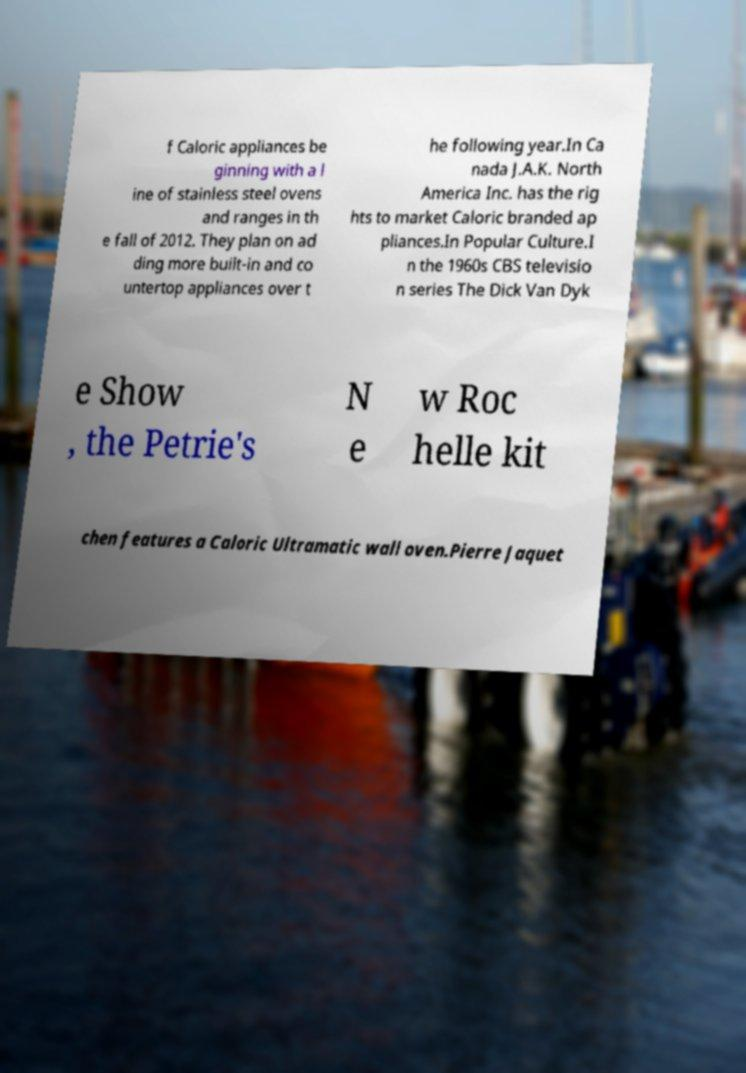What messages or text are displayed in this image? I need them in a readable, typed format. f Caloric appliances be ginning with a l ine of stainless steel ovens and ranges in th e fall of 2012. They plan on ad ding more built-in and co untertop appliances over t he following year.In Ca nada J.A.K. North America Inc. has the rig hts to market Caloric branded ap pliances.In Popular Culture.I n the 1960s CBS televisio n series The Dick Van Dyk e Show , the Petrie's N e w Roc helle kit chen features a Caloric Ultramatic wall oven.Pierre Jaquet 